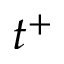<formula> <loc_0><loc_0><loc_500><loc_500>t ^ { + }</formula> 